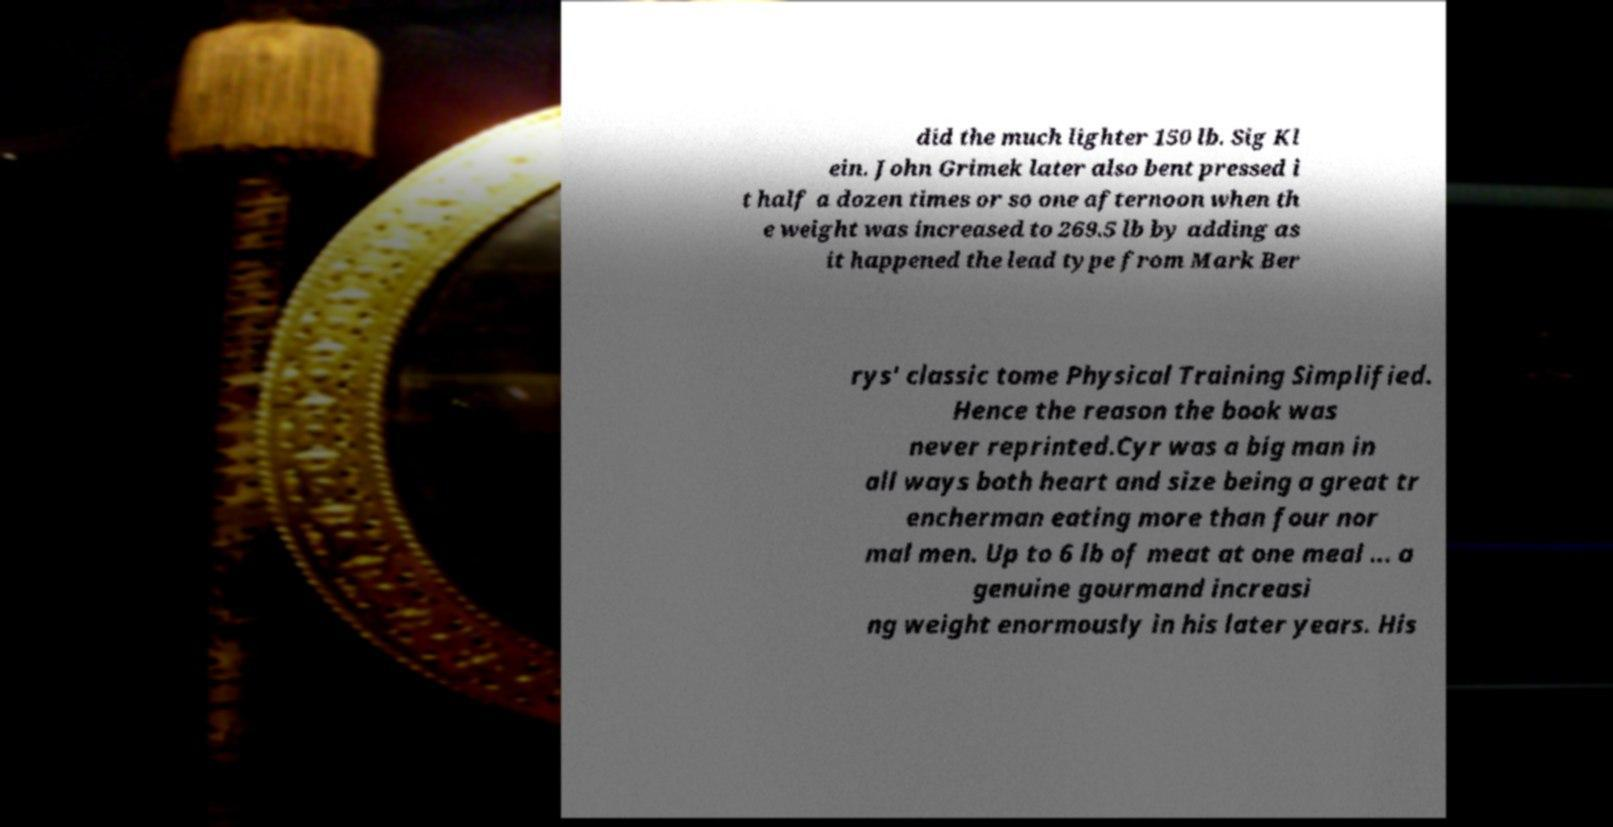Can you read and provide the text displayed in the image?This photo seems to have some interesting text. Can you extract and type it out for me? did the much lighter 150 lb. Sig Kl ein. John Grimek later also bent pressed i t half a dozen times or so one afternoon when th e weight was increased to 269.5 lb by adding as it happened the lead type from Mark Ber rys' classic tome Physical Training Simplified. Hence the reason the book was never reprinted.Cyr was a big man in all ways both heart and size being a great tr encherman eating more than four nor mal men. Up to 6 lb of meat at one meal ... a genuine gourmand increasi ng weight enormously in his later years. His 